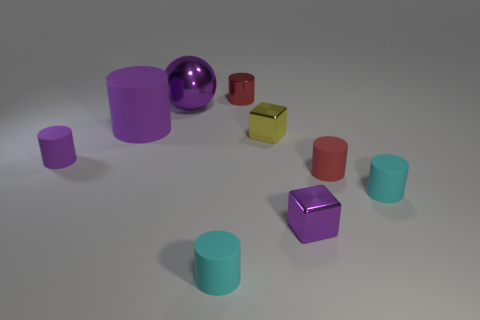Can you describe the shapes and their colors in the image? Certainly! In the image, there are several objects of varying shapes and colors. I can see cylindrical shapes in shades of purple and teal, a couple of cubes - one yellow, the other purple - and a sphere with a reflective purple surface. It's a collection that seems to evoke a sense of playful variety. 